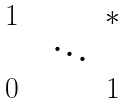Convert formula to latex. <formula><loc_0><loc_0><loc_500><loc_500>\begin{matrix} 1 & & & * \\ & & \ddots & & \\ 0 & & & 1 \end{matrix}</formula> 